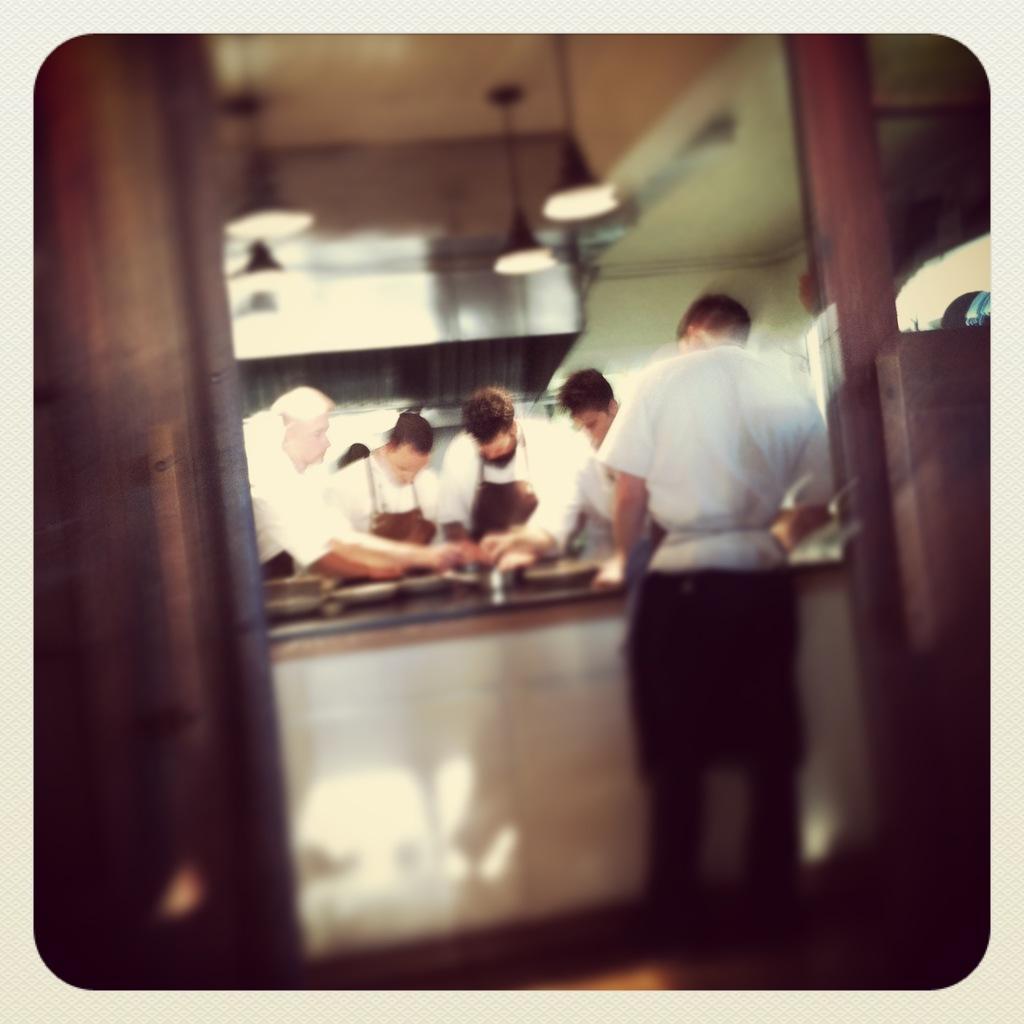How would you summarize this image in a sentence or two? In this image I can see a group of people are standing on the floor near the cabinet on which I can see plates and some objects. In the background I can see a wall, lights and door. This image looks like an edited photo. 